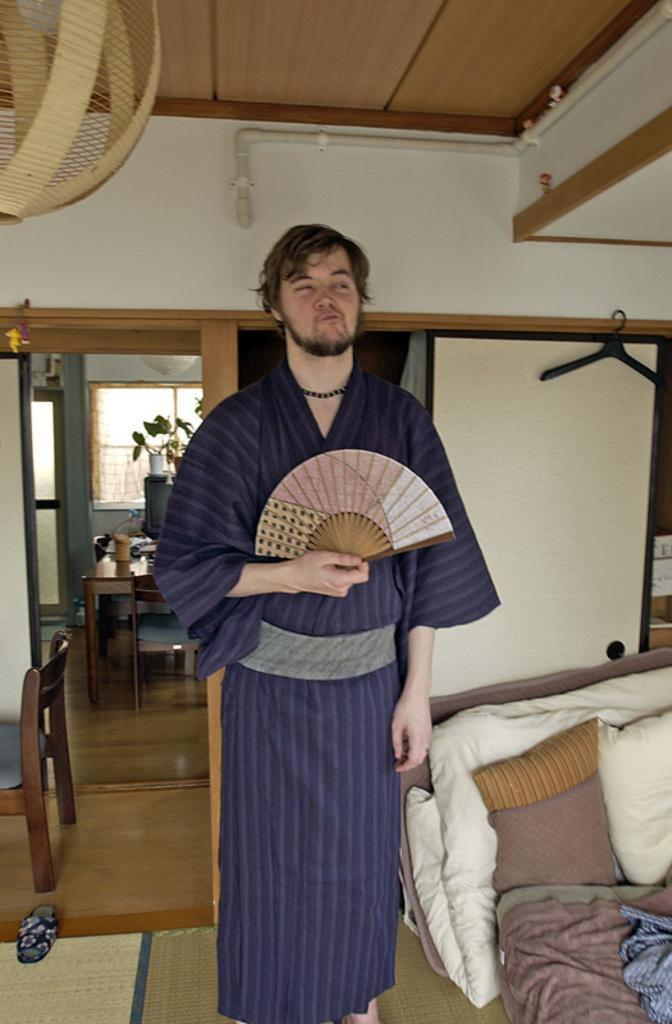What is the man in the image doing? The man is standing in the image. What object is the man holding? The man is holding a folding fan. What can be seen on the right side of the image? There is a pillow and a cloth on the right side of the image. What type of furniture is present in the image? There is a bed, a table, a chair, and a hanger behind the man. What is visible through the window behind the man? There is a water plant visible through the window. What type of authority does the man have in the image? The image does not provide any information about the man's authority or position. How many men are present in the image? There is only one man present in the image. 